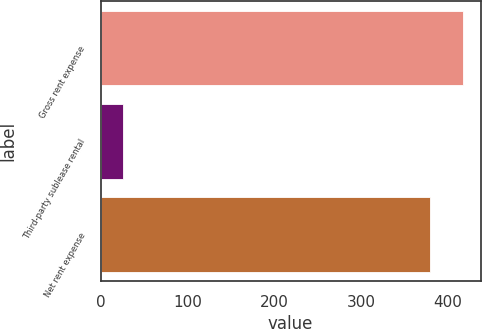Convert chart to OTSL. <chart><loc_0><loc_0><loc_500><loc_500><bar_chart><fcel>Gross rent expense<fcel>Third-party sublease rental<fcel>Net rent expense<nl><fcel>416.9<fcel>25.4<fcel>379<nl></chart> 